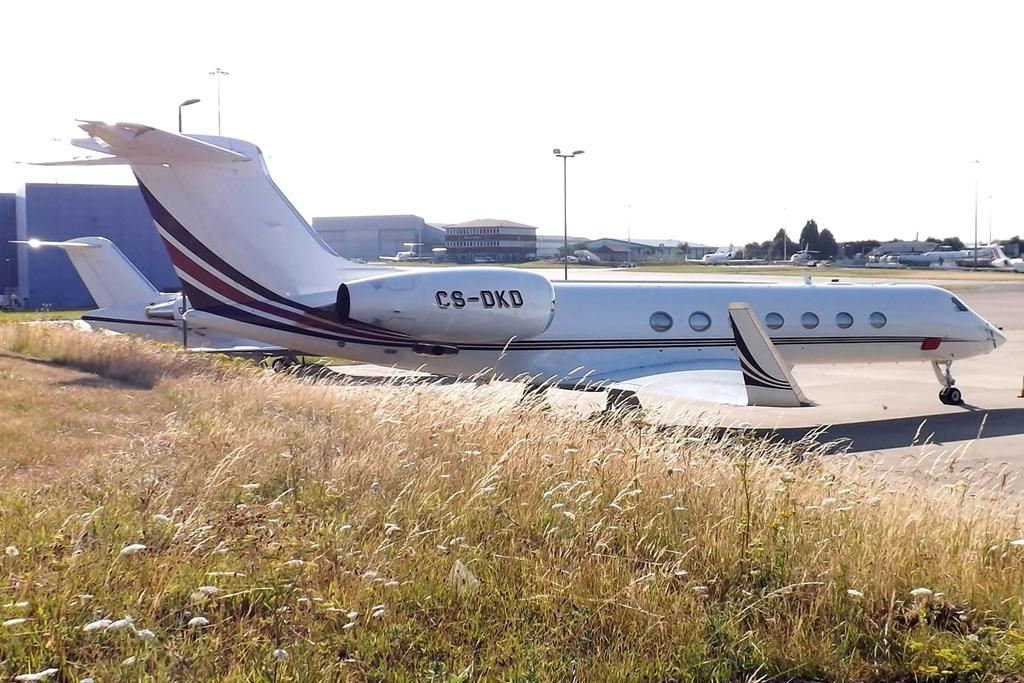<image>
Write a terse but informative summary of the picture. Cs-dkd wrote on a white and black airplane. 